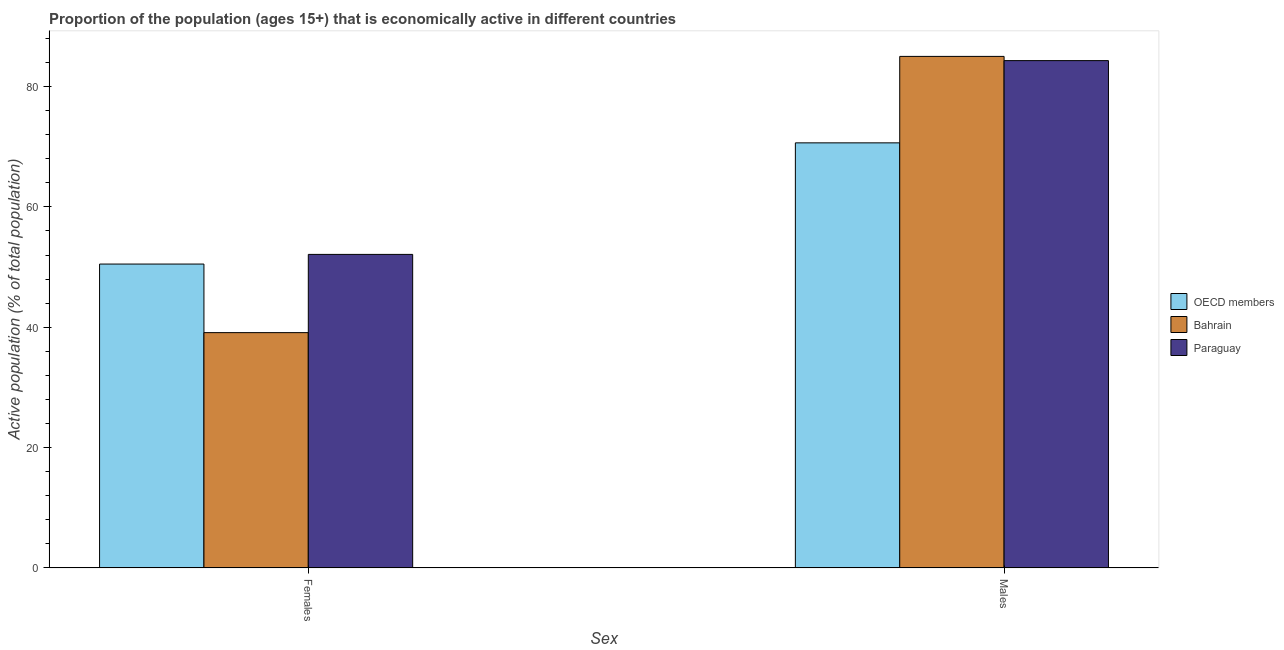How many bars are there on the 2nd tick from the left?
Give a very brief answer. 3. What is the label of the 1st group of bars from the left?
Ensure brevity in your answer.  Females. What is the percentage of economically active female population in Bahrain?
Provide a short and direct response. 39.1. Across all countries, what is the minimum percentage of economically active female population?
Make the answer very short. 39.1. In which country was the percentage of economically active male population maximum?
Provide a short and direct response. Bahrain. In which country was the percentage of economically active male population minimum?
Ensure brevity in your answer.  OECD members. What is the total percentage of economically active male population in the graph?
Offer a terse response. 239.94. What is the difference between the percentage of economically active male population in Paraguay and that in Bahrain?
Keep it short and to the point. -0.7. What is the difference between the percentage of economically active male population in OECD members and the percentage of economically active female population in Paraguay?
Give a very brief answer. 18.54. What is the average percentage of economically active male population per country?
Offer a very short reply. 79.98. What is the difference between the percentage of economically active male population and percentage of economically active female population in OECD members?
Keep it short and to the point. 20.14. What is the ratio of the percentage of economically active male population in Bahrain to that in OECD members?
Keep it short and to the point. 1.2. Is the percentage of economically active male population in OECD members less than that in Paraguay?
Give a very brief answer. Yes. In how many countries, is the percentage of economically active male population greater than the average percentage of economically active male population taken over all countries?
Offer a very short reply. 2. What does the 2nd bar from the left in Males represents?
Your answer should be very brief. Bahrain. What does the 1st bar from the right in Males represents?
Offer a very short reply. Paraguay. How many countries are there in the graph?
Your response must be concise. 3. What is the difference between two consecutive major ticks on the Y-axis?
Ensure brevity in your answer.  20. Are the values on the major ticks of Y-axis written in scientific E-notation?
Offer a terse response. No. Does the graph contain any zero values?
Your answer should be compact. No. What is the title of the graph?
Your answer should be very brief. Proportion of the population (ages 15+) that is economically active in different countries. Does "Burundi" appear as one of the legend labels in the graph?
Offer a very short reply. No. What is the label or title of the X-axis?
Ensure brevity in your answer.  Sex. What is the label or title of the Y-axis?
Your response must be concise. Active population (% of total population). What is the Active population (% of total population) of OECD members in Females?
Provide a succinct answer. 50.5. What is the Active population (% of total population) in Bahrain in Females?
Make the answer very short. 39.1. What is the Active population (% of total population) of Paraguay in Females?
Keep it short and to the point. 52.1. What is the Active population (% of total population) in OECD members in Males?
Make the answer very short. 70.64. What is the Active population (% of total population) in Bahrain in Males?
Your answer should be compact. 85. What is the Active population (% of total population) of Paraguay in Males?
Ensure brevity in your answer.  84.3. Across all Sex, what is the maximum Active population (% of total population) of OECD members?
Make the answer very short. 70.64. Across all Sex, what is the maximum Active population (% of total population) in Bahrain?
Make the answer very short. 85. Across all Sex, what is the maximum Active population (% of total population) in Paraguay?
Make the answer very short. 84.3. Across all Sex, what is the minimum Active population (% of total population) of OECD members?
Provide a succinct answer. 50.5. Across all Sex, what is the minimum Active population (% of total population) of Bahrain?
Provide a short and direct response. 39.1. Across all Sex, what is the minimum Active population (% of total population) of Paraguay?
Your answer should be very brief. 52.1. What is the total Active population (% of total population) of OECD members in the graph?
Offer a terse response. 121.13. What is the total Active population (% of total population) in Bahrain in the graph?
Your response must be concise. 124.1. What is the total Active population (% of total population) of Paraguay in the graph?
Keep it short and to the point. 136.4. What is the difference between the Active population (% of total population) in OECD members in Females and that in Males?
Provide a succinct answer. -20.14. What is the difference between the Active population (% of total population) of Bahrain in Females and that in Males?
Your response must be concise. -45.9. What is the difference between the Active population (% of total population) in Paraguay in Females and that in Males?
Your response must be concise. -32.2. What is the difference between the Active population (% of total population) in OECD members in Females and the Active population (% of total population) in Bahrain in Males?
Offer a very short reply. -34.5. What is the difference between the Active population (% of total population) in OECD members in Females and the Active population (% of total population) in Paraguay in Males?
Offer a very short reply. -33.8. What is the difference between the Active population (% of total population) of Bahrain in Females and the Active population (% of total population) of Paraguay in Males?
Provide a short and direct response. -45.2. What is the average Active population (% of total population) in OECD members per Sex?
Your response must be concise. 60.57. What is the average Active population (% of total population) in Bahrain per Sex?
Offer a terse response. 62.05. What is the average Active population (% of total population) in Paraguay per Sex?
Your response must be concise. 68.2. What is the difference between the Active population (% of total population) of OECD members and Active population (% of total population) of Bahrain in Females?
Provide a succinct answer. 11.4. What is the difference between the Active population (% of total population) in OECD members and Active population (% of total population) in Paraguay in Females?
Ensure brevity in your answer.  -1.6. What is the difference between the Active population (% of total population) of OECD members and Active population (% of total population) of Bahrain in Males?
Your response must be concise. -14.36. What is the difference between the Active population (% of total population) of OECD members and Active population (% of total population) of Paraguay in Males?
Your response must be concise. -13.66. What is the ratio of the Active population (% of total population) of OECD members in Females to that in Males?
Offer a very short reply. 0.71. What is the ratio of the Active population (% of total population) of Bahrain in Females to that in Males?
Offer a terse response. 0.46. What is the ratio of the Active population (% of total population) of Paraguay in Females to that in Males?
Your response must be concise. 0.62. What is the difference between the highest and the second highest Active population (% of total population) in OECD members?
Provide a short and direct response. 20.14. What is the difference between the highest and the second highest Active population (% of total population) of Bahrain?
Offer a very short reply. 45.9. What is the difference between the highest and the second highest Active population (% of total population) of Paraguay?
Your answer should be compact. 32.2. What is the difference between the highest and the lowest Active population (% of total population) of OECD members?
Your answer should be very brief. 20.14. What is the difference between the highest and the lowest Active population (% of total population) in Bahrain?
Your response must be concise. 45.9. What is the difference between the highest and the lowest Active population (% of total population) in Paraguay?
Provide a succinct answer. 32.2. 